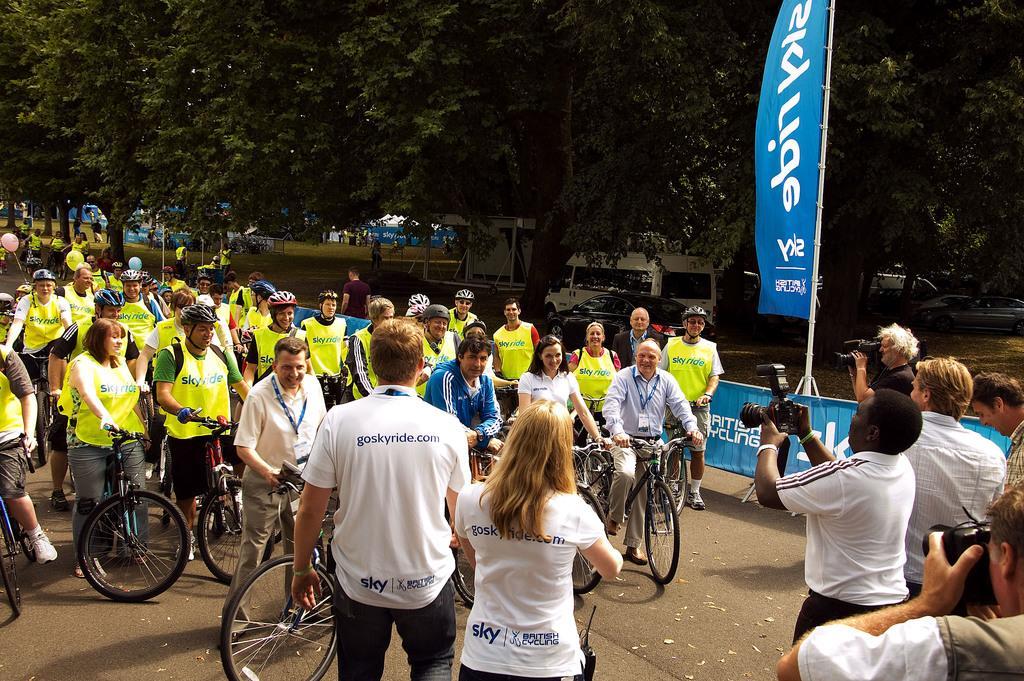Describe this image in one or two sentences. In this picture we can see a group of people on the bicycles and the other people in front of them holding cameras. 